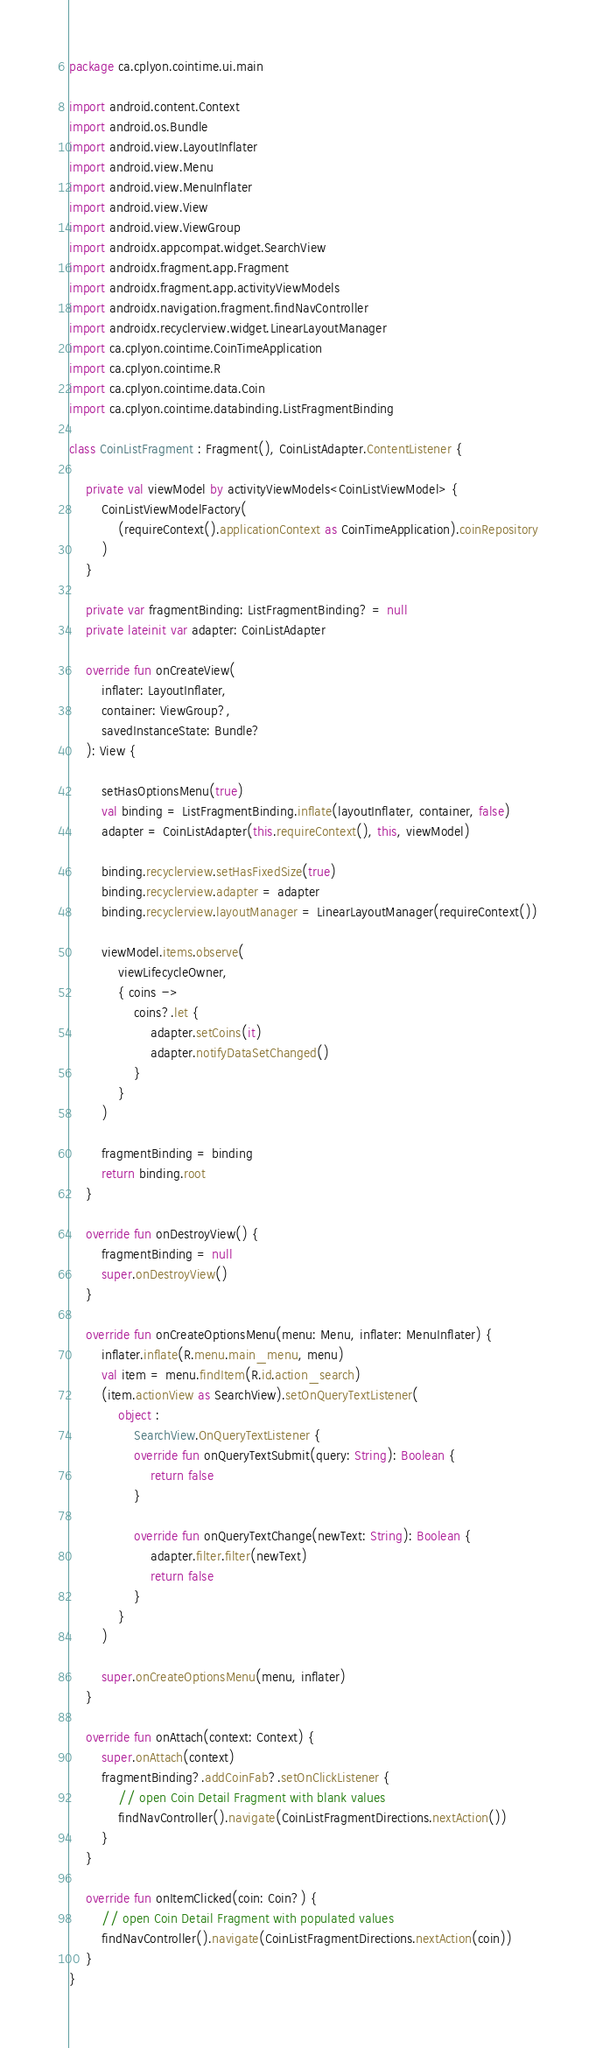Convert code to text. <code><loc_0><loc_0><loc_500><loc_500><_Kotlin_>package ca.cplyon.cointime.ui.main

import android.content.Context
import android.os.Bundle
import android.view.LayoutInflater
import android.view.Menu
import android.view.MenuInflater
import android.view.View
import android.view.ViewGroup
import androidx.appcompat.widget.SearchView
import androidx.fragment.app.Fragment
import androidx.fragment.app.activityViewModels
import androidx.navigation.fragment.findNavController
import androidx.recyclerview.widget.LinearLayoutManager
import ca.cplyon.cointime.CoinTimeApplication
import ca.cplyon.cointime.R
import ca.cplyon.cointime.data.Coin
import ca.cplyon.cointime.databinding.ListFragmentBinding

class CoinListFragment : Fragment(), CoinListAdapter.ContentListener {

    private val viewModel by activityViewModels<CoinListViewModel> {
        CoinListViewModelFactory(
            (requireContext().applicationContext as CoinTimeApplication).coinRepository
        )
    }

    private var fragmentBinding: ListFragmentBinding? = null
    private lateinit var adapter: CoinListAdapter

    override fun onCreateView(
        inflater: LayoutInflater,
        container: ViewGroup?,
        savedInstanceState: Bundle?
    ): View {

        setHasOptionsMenu(true)
        val binding = ListFragmentBinding.inflate(layoutInflater, container, false)
        adapter = CoinListAdapter(this.requireContext(), this, viewModel)

        binding.recyclerview.setHasFixedSize(true)
        binding.recyclerview.adapter = adapter
        binding.recyclerview.layoutManager = LinearLayoutManager(requireContext())

        viewModel.items.observe(
            viewLifecycleOwner,
            { coins ->
                coins?.let {
                    adapter.setCoins(it)
                    adapter.notifyDataSetChanged()
                }
            }
        )

        fragmentBinding = binding
        return binding.root
    }

    override fun onDestroyView() {
        fragmentBinding = null
        super.onDestroyView()
    }

    override fun onCreateOptionsMenu(menu: Menu, inflater: MenuInflater) {
        inflater.inflate(R.menu.main_menu, menu)
        val item = menu.findItem(R.id.action_search)
        (item.actionView as SearchView).setOnQueryTextListener(
            object :
                SearchView.OnQueryTextListener {
                override fun onQueryTextSubmit(query: String): Boolean {
                    return false
                }

                override fun onQueryTextChange(newText: String): Boolean {
                    adapter.filter.filter(newText)
                    return false
                }
            }
        )

        super.onCreateOptionsMenu(menu, inflater)
    }

    override fun onAttach(context: Context) {
        super.onAttach(context)
        fragmentBinding?.addCoinFab?.setOnClickListener {
            // open Coin Detail Fragment with blank values
            findNavController().navigate(CoinListFragmentDirections.nextAction())
        }
    }

    override fun onItemClicked(coin: Coin?) {
        // open Coin Detail Fragment with populated values
        findNavController().navigate(CoinListFragmentDirections.nextAction(coin))
    }
}
</code> 